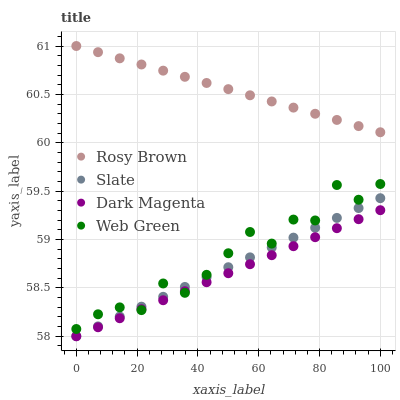Does Dark Magenta have the minimum area under the curve?
Answer yes or no. Yes. Does Rosy Brown have the maximum area under the curve?
Answer yes or no. Yes. Does Rosy Brown have the minimum area under the curve?
Answer yes or no. No. Does Dark Magenta have the maximum area under the curve?
Answer yes or no. No. Is Dark Magenta the smoothest?
Answer yes or no. Yes. Is Web Green the roughest?
Answer yes or no. Yes. Is Rosy Brown the smoothest?
Answer yes or no. No. Is Rosy Brown the roughest?
Answer yes or no. No. Does Slate have the lowest value?
Answer yes or no. Yes. Does Rosy Brown have the lowest value?
Answer yes or no. No. Does Rosy Brown have the highest value?
Answer yes or no. Yes. Does Dark Magenta have the highest value?
Answer yes or no. No. Is Slate less than Rosy Brown?
Answer yes or no. Yes. Is Rosy Brown greater than Dark Magenta?
Answer yes or no. Yes. Does Slate intersect Web Green?
Answer yes or no. Yes. Is Slate less than Web Green?
Answer yes or no. No. Is Slate greater than Web Green?
Answer yes or no. No. Does Slate intersect Rosy Brown?
Answer yes or no. No. 